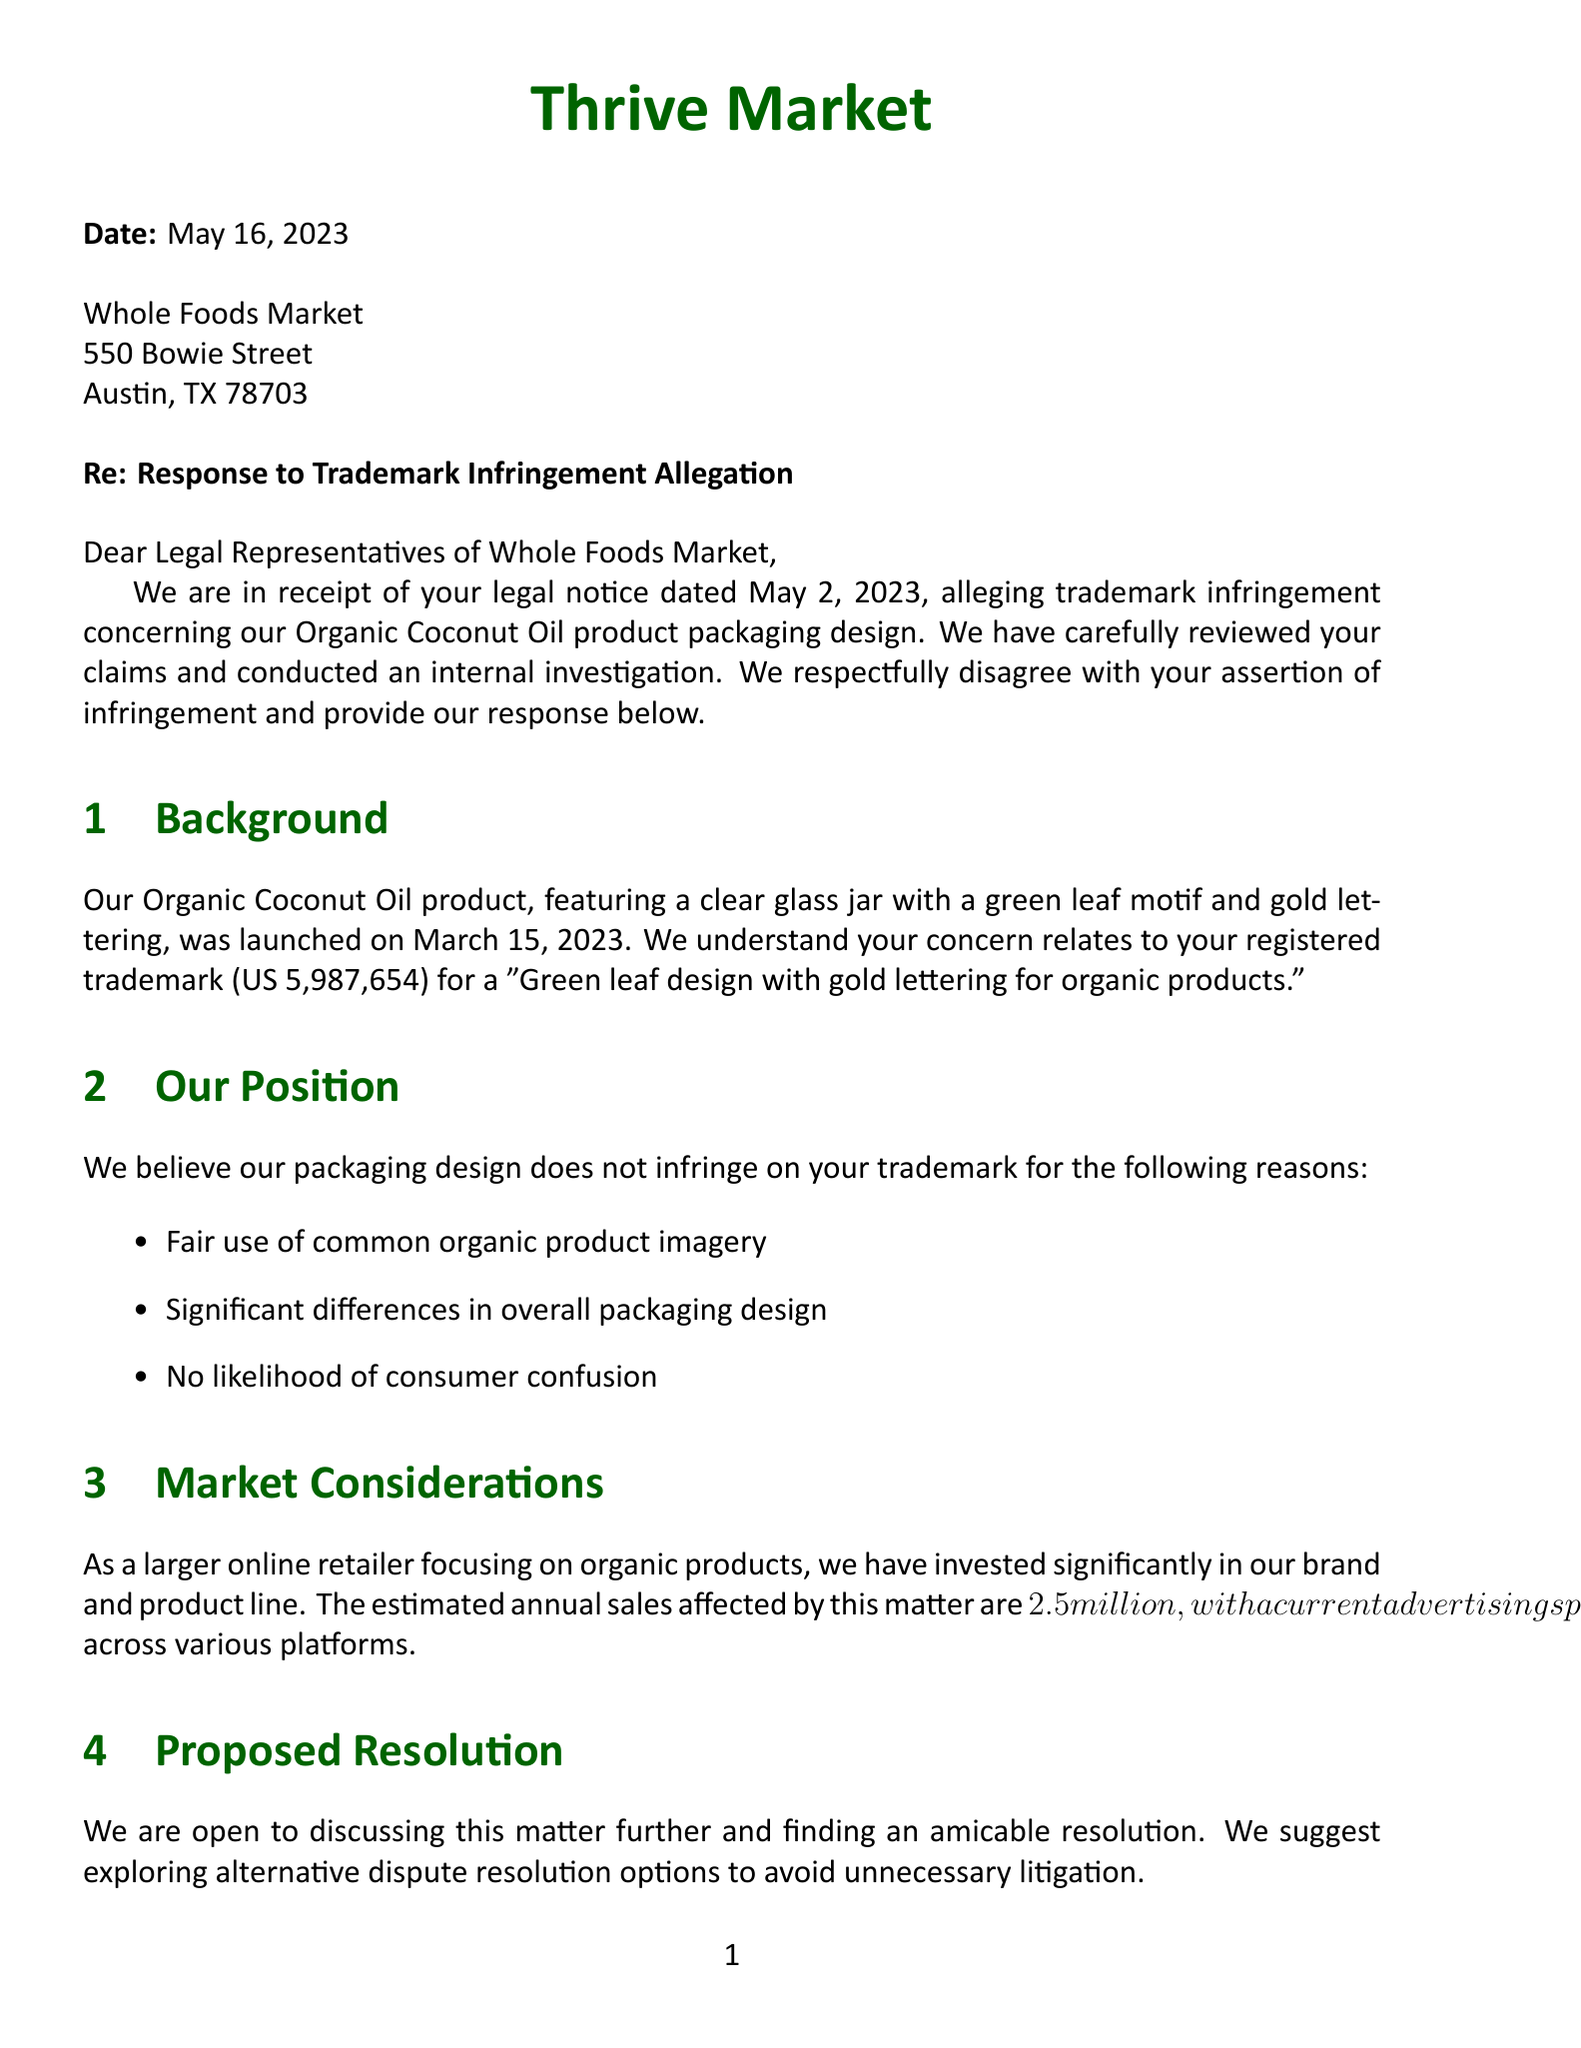What is the name of the competitor? The document states that the competitor is Whole Foods Market.
Answer: Whole Foods Market What is the filing date of the trademark registration? The filing date provided in the document is September 10, 2018.
Answer: September 10, 2018 What are the primary demands from Whole Foods Market? The primary demands include actions like ceasing the use of the packaging design and recalling the products.
Answer: Cease and desist use of infringing packaging design What is the potential rebranding cost mentioned? The document outlines the potential rebranding cost as $500,000.
Answer: $500,000 What date was the trademark registration granted? The document states that the trademark registration date is April 3, 2019.
Answer: April 3, 2019 What is the estimated annual sales affected by the allegation? The document indicates that the estimated sales affected are $2.5 million annually.
Answer: $2.5 million What is the deadline for response to the legal notice? The deadline for response as noted in the document is May 16, 2023.
Answer: May 16, 2023 What are the advertising platforms mentioned for the current ad spend? The document lists Google Ads, Facebook, Instagram, and Amazon as advertising platforms.
Answer: Google Ads, Facebook, Instagram, Amazon What is the suggested method for resolving the dispute? The letter suggests discussing alternative dispute resolution options.
Answer: Alternative dispute resolution options 